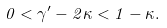<formula> <loc_0><loc_0><loc_500><loc_500>0 < \gamma ^ { \prime } - 2 \kappa < 1 - \kappa .</formula> 